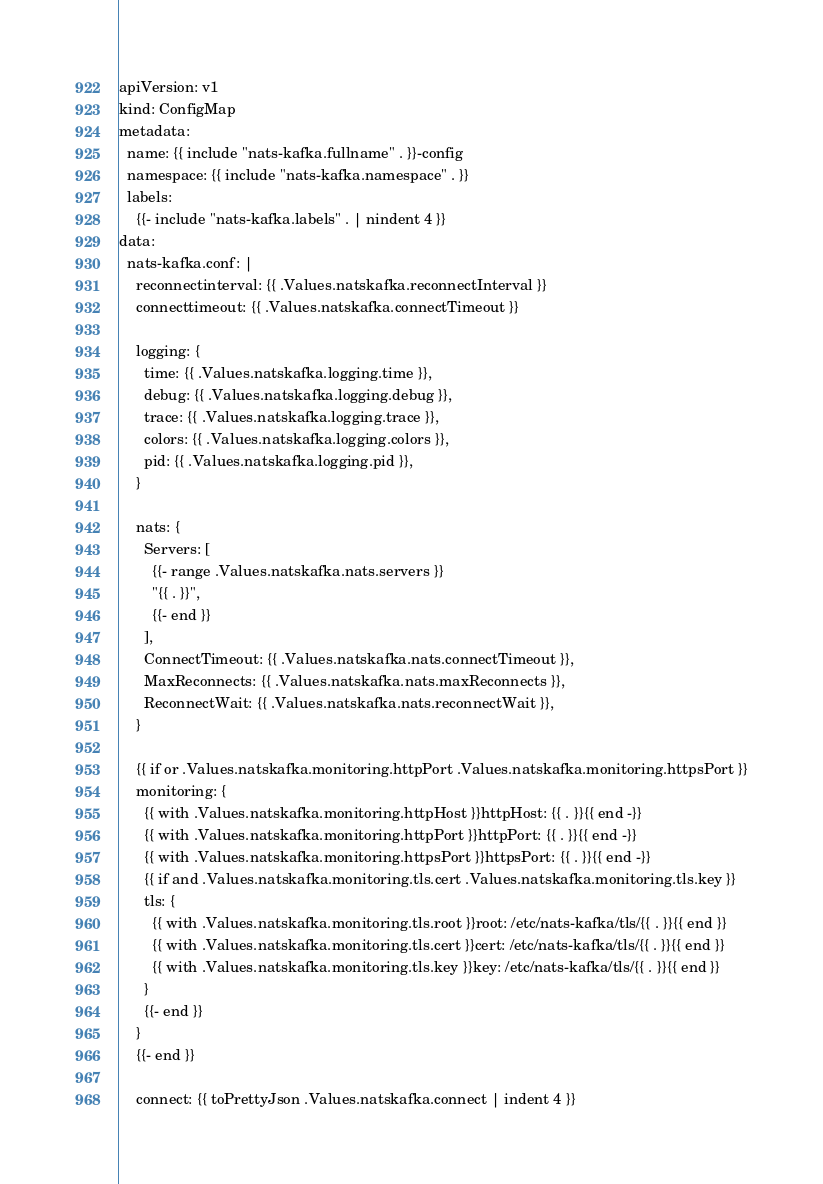<code> <loc_0><loc_0><loc_500><loc_500><_YAML_>apiVersion: v1
kind: ConfigMap
metadata:
  name: {{ include "nats-kafka.fullname" . }}-config
  namespace: {{ include "nats-kafka.namespace" . }}
  labels:
    {{- include "nats-kafka.labels" . | nindent 4 }}
data:
  nats-kafka.conf: |
    reconnectinterval: {{ .Values.natskafka.reconnectInterval }}
    connecttimeout: {{ .Values.natskafka.connectTimeout }}

    logging: {
      time: {{ .Values.natskafka.logging.time }},
      debug: {{ .Values.natskafka.logging.debug }},
      trace: {{ .Values.natskafka.logging.trace }},
      colors: {{ .Values.natskafka.logging.colors }},
      pid: {{ .Values.natskafka.logging.pid }},
    }

    nats: {
      Servers: [
        {{- range .Values.natskafka.nats.servers }}
        "{{ . }}",
        {{- end }}
      ],
      ConnectTimeout: {{ .Values.natskafka.nats.connectTimeout }},
      MaxReconnects: {{ .Values.natskafka.nats.maxReconnects }},
      ReconnectWait: {{ .Values.natskafka.nats.reconnectWait }},
    }

    {{ if or .Values.natskafka.monitoring.httpPort .Values.natskafka.monitoring.httpsPort }}
    monitoring: {
      {{ with .Values.natskafka.monitoring.httpHost }}httpHost: {{ . }}{{ end -}}
      {{ with .Values.natskafka.monitoring.httpPort }}httpPort: {{ . }}{{ end -}}
      {{ with .Values.natskafka.monitoring.httpsPort }}httpsPort: {{ . }}{{ end -}}
      {{ if and .Values.natskafka.monitoring.tls.cert .Values.natskafka.monitoring.tls.key }}
      tls: {
        {{ with .Values.natskafka.monitoring.tls.root }}root: /etc/nats-kafka/tls/{{ . }}{{ end }}
        {{ with .Values.natskafka.monitoring.tls.cert }}cert: /etc/nats-kafka/tls/{{ . }}{{ end }}
        {{ with .Values.natskafka.monitoring.tls.key }}key: /etc/nats-kafka/tls/{{ . }}{{ end }}
      }
      {{- end }}
    }
    {{- end }}

    connect: {{ toPrettyJson .Values.natskafka.connect | indent 4 }}
</code> 